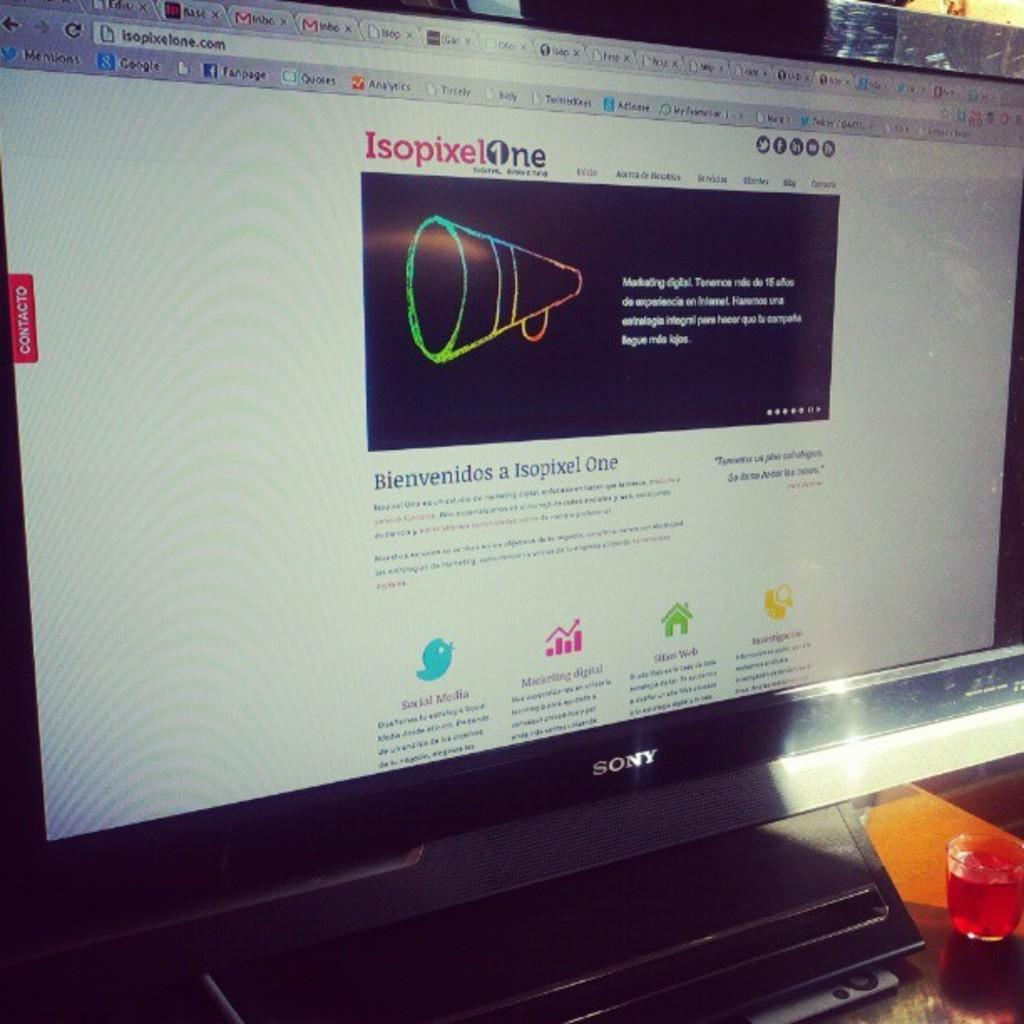<image>
Offer a succinct explanation of the picture presented. The home Page for the IsopixelOne internet website. 